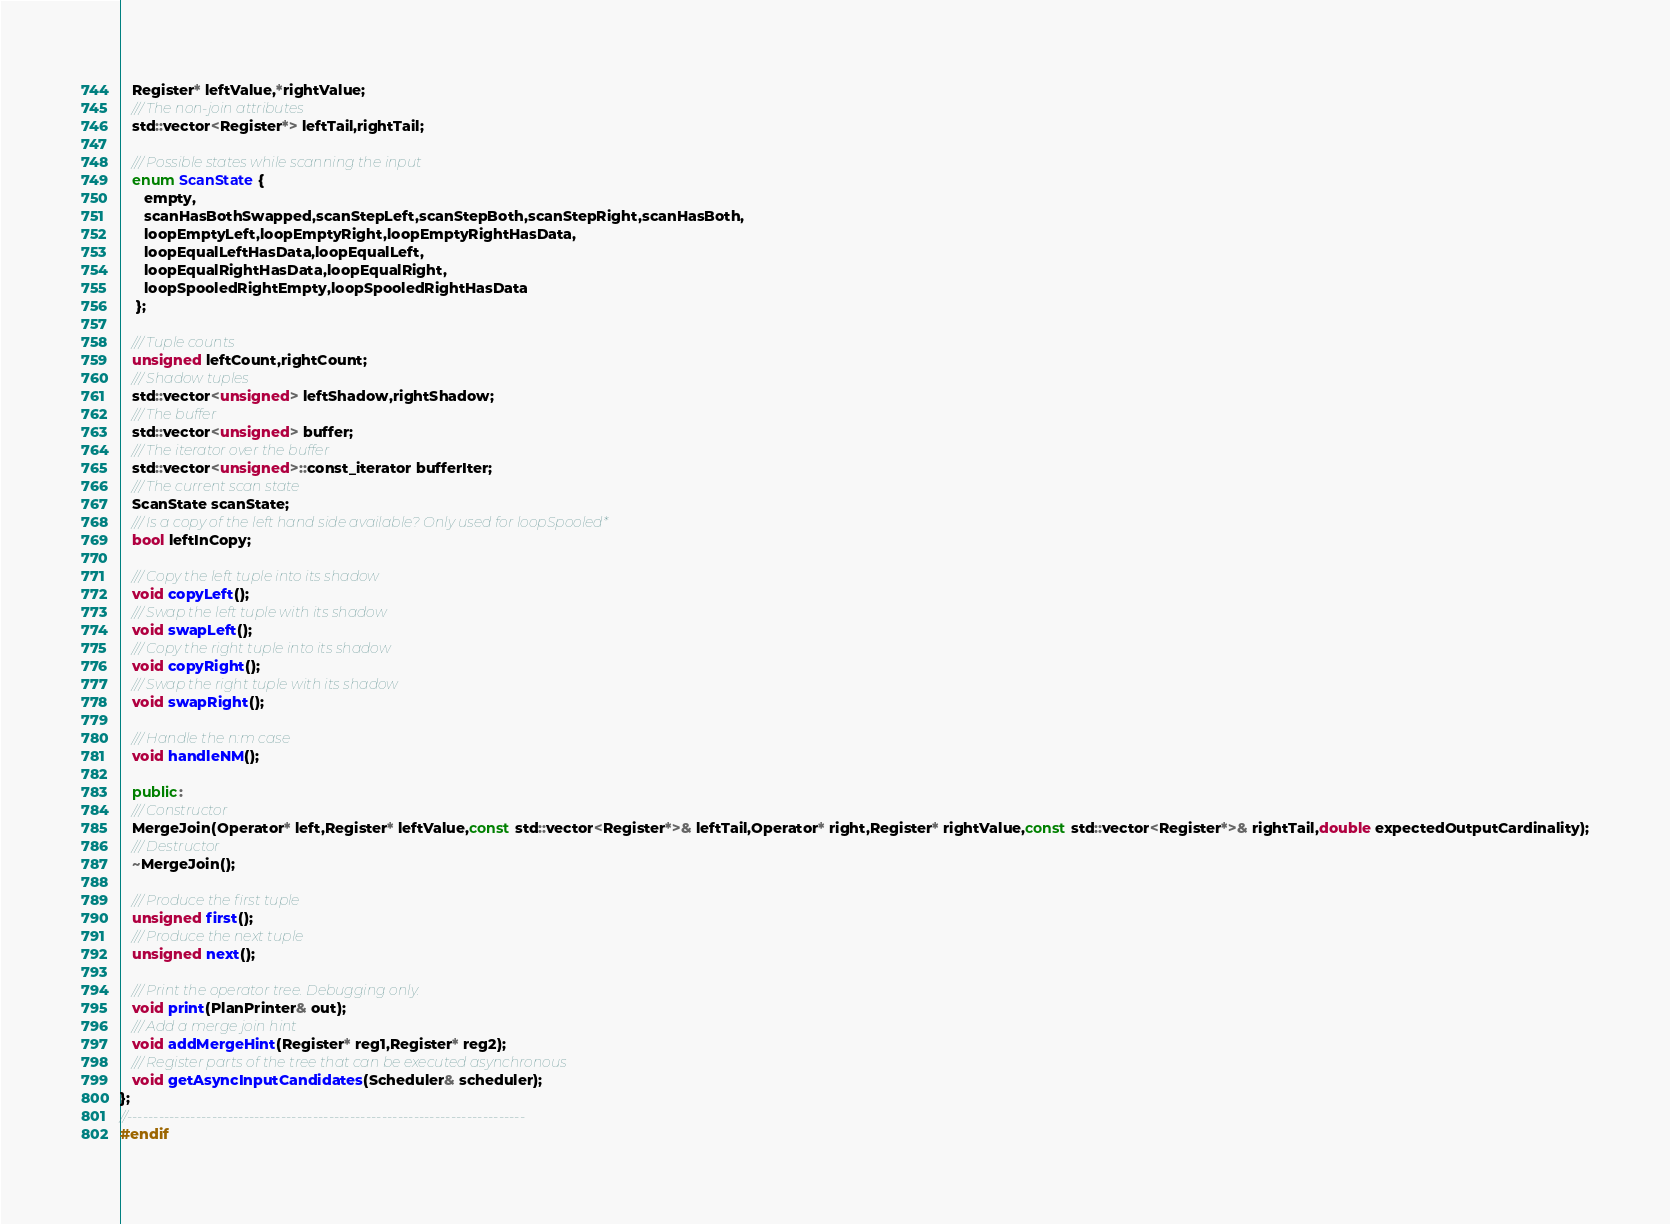Convert code to text. <code><loc_0><loc_0><loc_500><loc_500><_C++_>   Register* leftValue,*rightValue;
   /// The non-join attributes
   std::vector<Register*> leftTail,rightTail;

   /// Possible states while scanning the input
   enum ScanState {
      empty,
      scanHasBothSwapped,scanStepLeft,scanStepBoth,scanStepRight,scanHasBoth,
      loopEmptyLeft,loopEmptyRight,loopEmptyRightHasData,
      loopEqualLeftHasData,loopEqualLeft,
      loopEqualRightHasData,loopEqualRight,
      loopSpooledRightEmpty,loopSpooledRightHasData
    };

   /// Tuple counts
   unsigned leftCount,rightCount;
   /// Shadow tuples
   std::vector<unsigned> leftShadow,rightShadow;
   /// The buffer
   std::vector<unsigned> buffer;
   /// The iterator over the buffer
   std::vector<unsigned>::const_iterator bufferIter;
   /// The current scan state
   ScanState scanState;
   /// Is a copy of the left hand side available? Only used for loopSpooled*
   bool leftInCopy;

   /// Copy the left tuple into its shadow
   void copyLeft();
   /// Swap the left tuple with its shadow
   void swapLeft();
   /// Copy the right tuple into its shadow
   void copyRight();
   /// Swap the right tuple with its shadow
   void swapRight();

   /// Handle the n:m case
   void handleNM();

   public:
   /// Constructor
   MergeJoin(Operator* left,Register* leftValue,const std::vector<Register*>& leftTail,Operator* right,Register* rightValue,const std::vector<Register*>& rightTail,double expectedOutputCardinality);
   /// Destructor
   ~MergeJoin();

   /// Produce the first tuple
   unsigned first();
   /// Produce the next tuple
   unsigned next();

   /// Print the operator tree. Debugging only.
   void print(PlanPrinter& out);
   /// Add a merge join hint
   void addMergeHint(Register* reg1,Register* reg2);
   /// Register parts of the tree that can be executed asynchronous
   void getAsyncInputCandidates(Scheduler& scheduler);
};
//---------------------------------------------------------------------------
#endif
</code> 